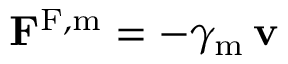Convert formula to latex. <formula><loc_0><loc_0><loc_500><loc_500>F ^ { F , m } = - \gamma _ { m } \, v</formula> 